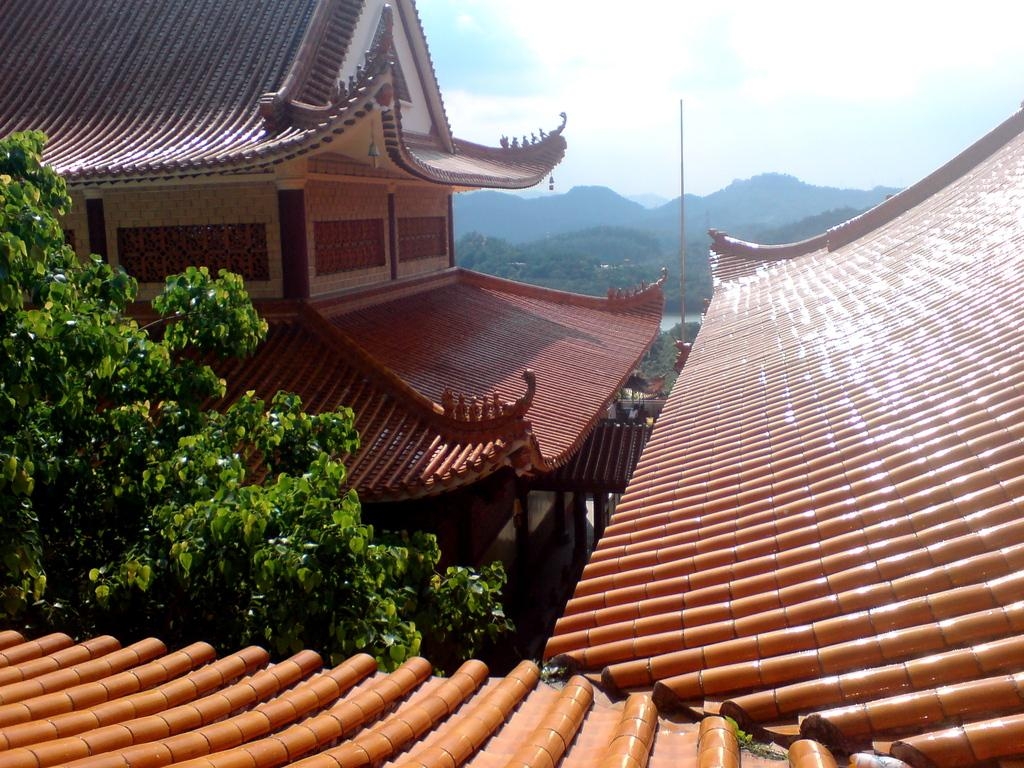What type of structures can be seen in the image? There are rooftops and a building in the image. What natural elements are present in the image? There is a tree and hills in the background of the image. What man-made object can be seen in the background of the image? There is a pole in the background of the image. What is visible in the sky in the image? Clouds are present in the sky in the image. How many art pieces are hanging on the rooftops in the image? There is no mention of any art pieces in the image; it features rooftops, a building, a tree, a pole, and hills in the background. What type of vest is the tree wearing in the image? Trees do not wear vests, so this question cannot be answered. 